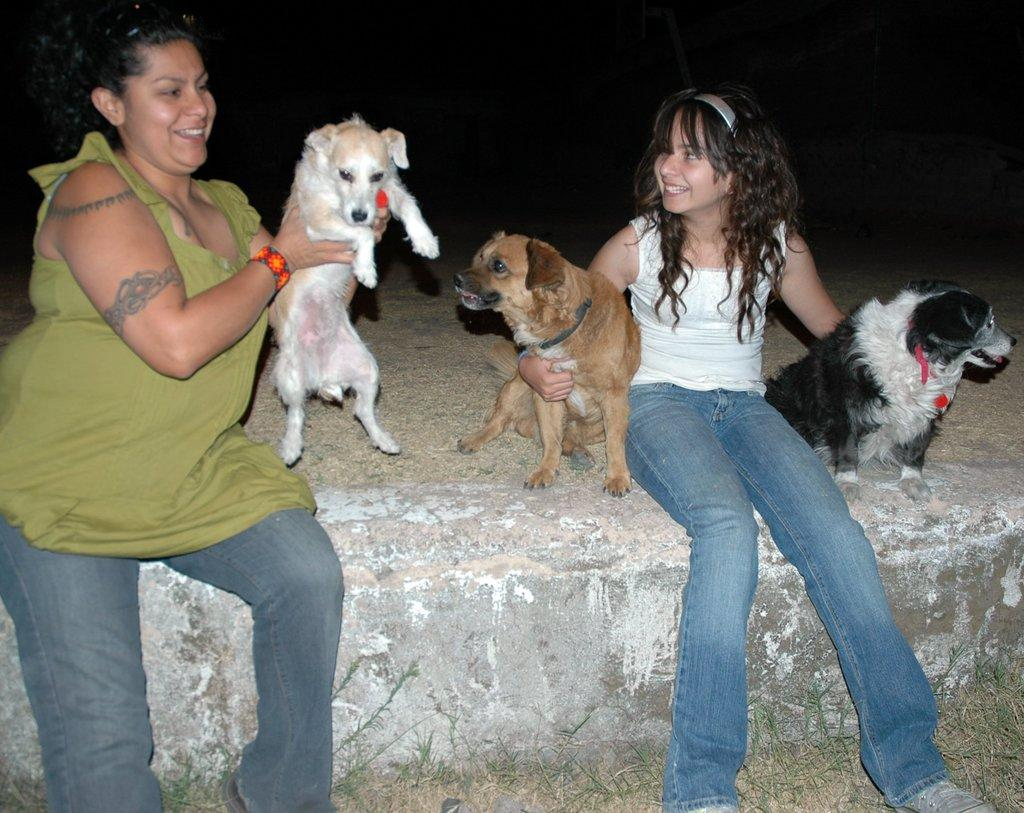Who are the people in the image? There is a woman and a girl in the image. What are the woman and the girl holding in the image? Both the woman and the girl are holding dogs. What is the color of the background in the image? The background of the image is dark. What type of terrain is visible in the image? There is grass on the ground in the image. How many lizards can be seen crawling on the gate in the image? There is no gate or lizards present in the image. What is the condition of the dogs in the image? The provided facts do not mention the condition of the dogs, only that they are being held by the woman and the girl. 